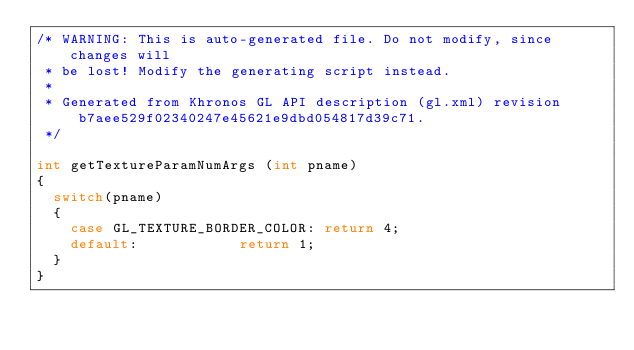Convert code to text. <code><loc_0><loc_0><loc_500><loc_500><_C++_>/* WARNING: This is auto-generated file. Do not modify, since changes will
 * be lost! Modify the generating script instead.
 *
 * Generated from Khronos GL API description (gl.xml) revision b7aee529f02340247e45621e9dbd054817d39c71.
 */

int getTextureParamNumArgs (int pname)
{
	switch(pname)
	{
		case GL_TEXTURE_BORDER_COLOR:	return 4;
		default:						return 1;
	}
}
</code> 